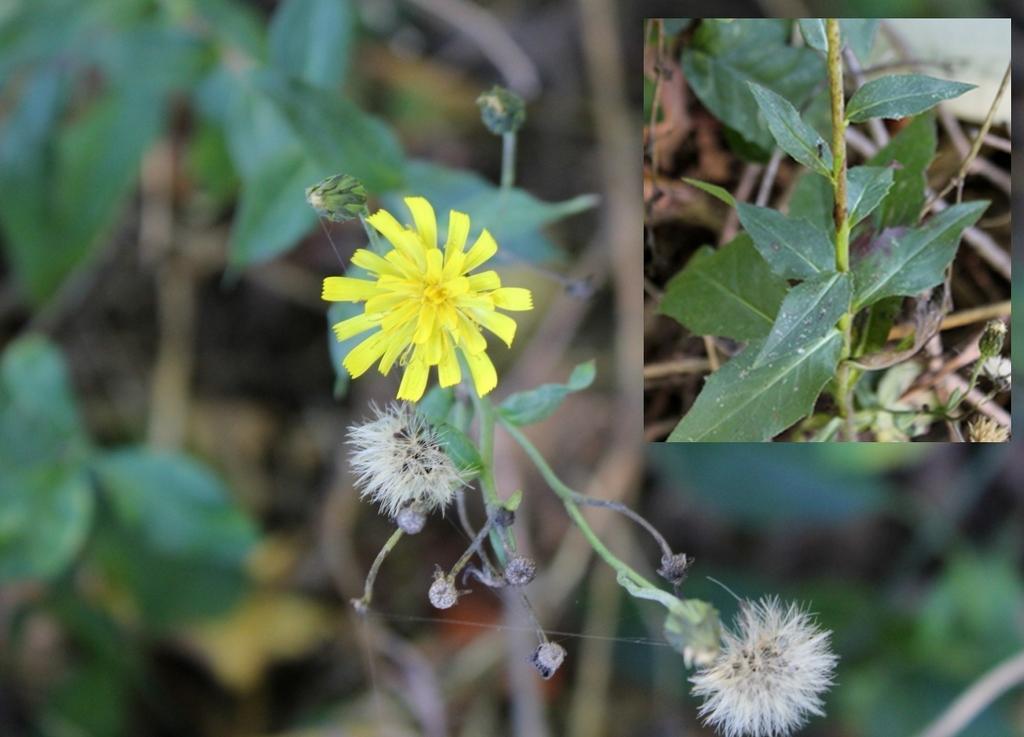How would you summarize this image in a sentence or two? In this image there are plants and we can see flowers. In the center we can see a yellow flower. 